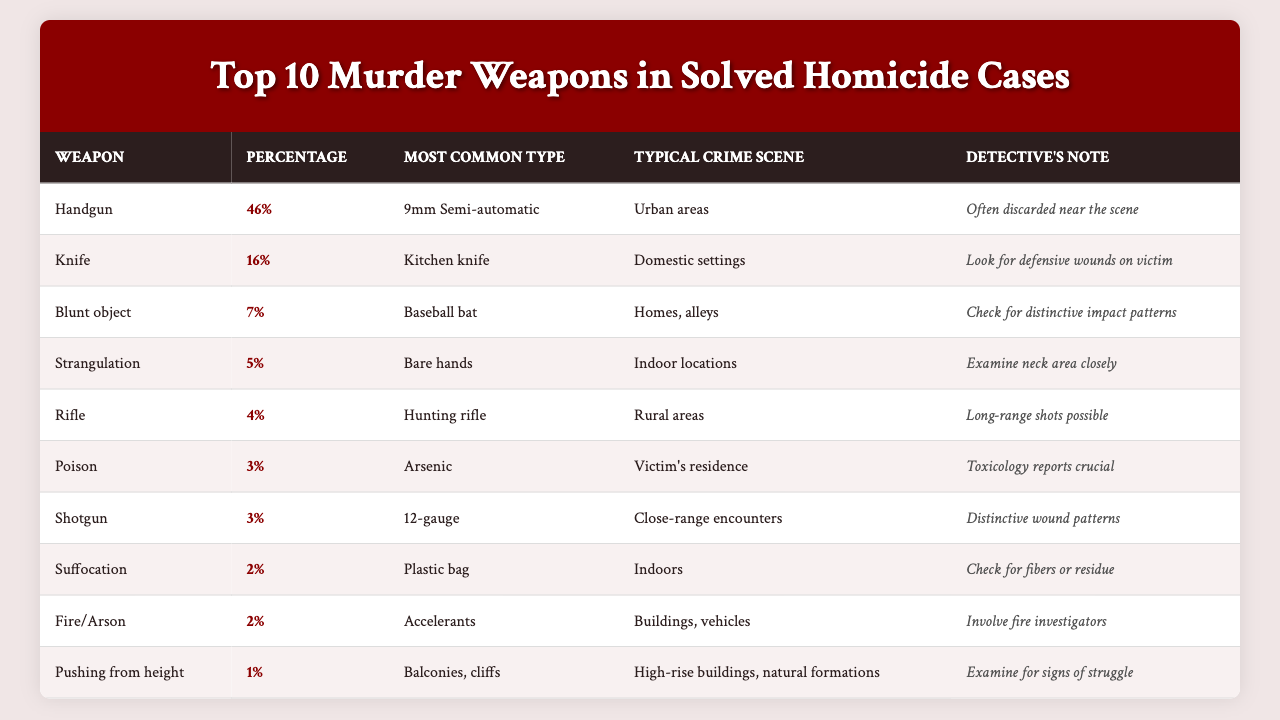What is the most common murder weapon used in solved homicide cases? The table clearly shows that the most common murder weapon is a "Handgun," as it appears at the top of the list.
Answer: Handgun What percentage of homicides are committed using knives? According to the table, the second entry indicates that "Knife" is used in 16% of solved homicide cases.
Answer: 16% Which murder weapon has the lowest percentage of use in solved homicide cases? By examining the last entry in the table, "Pushing from height" is listed with a percentage of 1%, making it the least common weapon.
Answer: 1% If a detective finds a murder case involving a blunt object, what is the most common type of weapon they are likely to encounter? The table notes that under "Blunt object," the most common type of weapon is a "Baseball bat."
Answer: Baseball bat What is the typical crime scene for a murder committed with a rifle? The entry for "Rifle" indicates that the typical crime scene is in "Rural areas."
Answer: Rural areas What percentage of solved homicide cases involve poisoning? The table specifies that the percentage of homicides involving "Poison" is 3%.
Answer: 3% Out of the top 10 murder weapons, how many involve firearms? By analyzing the table, "Handgun," "Rifle," and "Shotgun" are three different types of firearms listed in the top 10. Therefore, there are three firearms.
Answer: 3 Which murder weapon is most likely to occur in urban areas? The table specifies that a "Handgun" is the weapon most commonly used in urban areas, as shown in its corresponding typical crime scene.
Answer: Handgun Are there any murder weapons that have a percentage less than 3%? The table shows "Suffocation," "Fire/Arson," and "Pushing from height," each with a percentage of 2% or less, confirming that there are weapons with less than 3%.
Answer: Yes Calculate the total percentage of homicides committed by the top three murder weapons. The top three murder weapons are "Handgun" (46%), "Knife" (16%), and "Blunt object" (7%). Adding these percentages gives: 46 + 16 + 7 = 69%.
Answer: 69% 